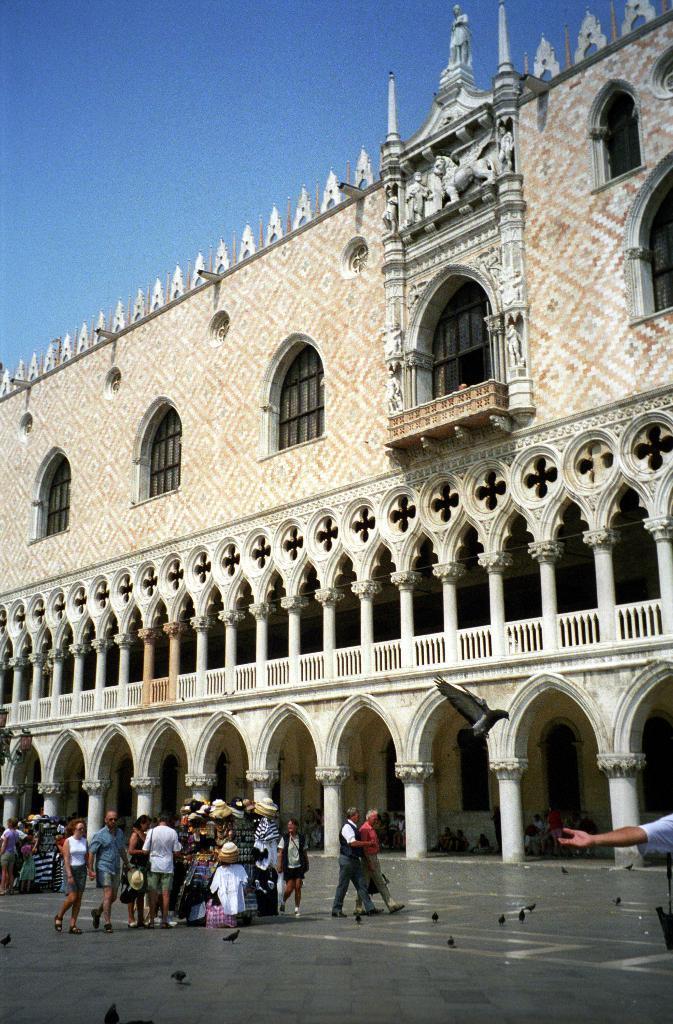In one or two sentences, can you explain what this image depicts? In this image I can see the ground, few birds and few persons. I can see a huge building which is cream and brown in color, few windows and few statues to the building. In the background I can see the sky. 